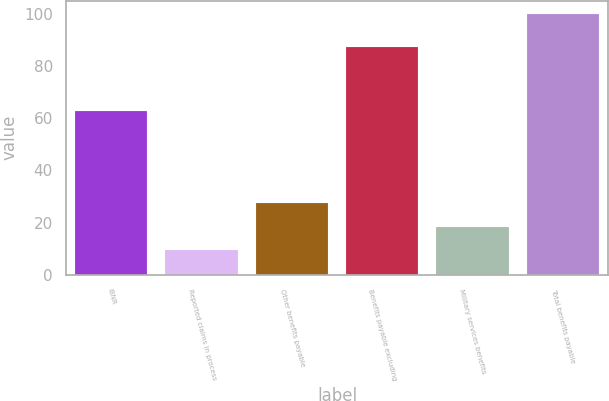Convert chart. <chart><loc_0><loc_0><loc_500><loc_500><bar_chart><fcel>IBNR<fcel>Reported claims in process<fcel>Other benefits payable<fcel>Benefits payable excluding<fcel>Military services benefits<fcel>Total benefits payable<nl><fcel>62.8<fcel>9.4<fcel>27.52<fcel>87.3<fcel>18.46<fcel>100<nl></chart> 